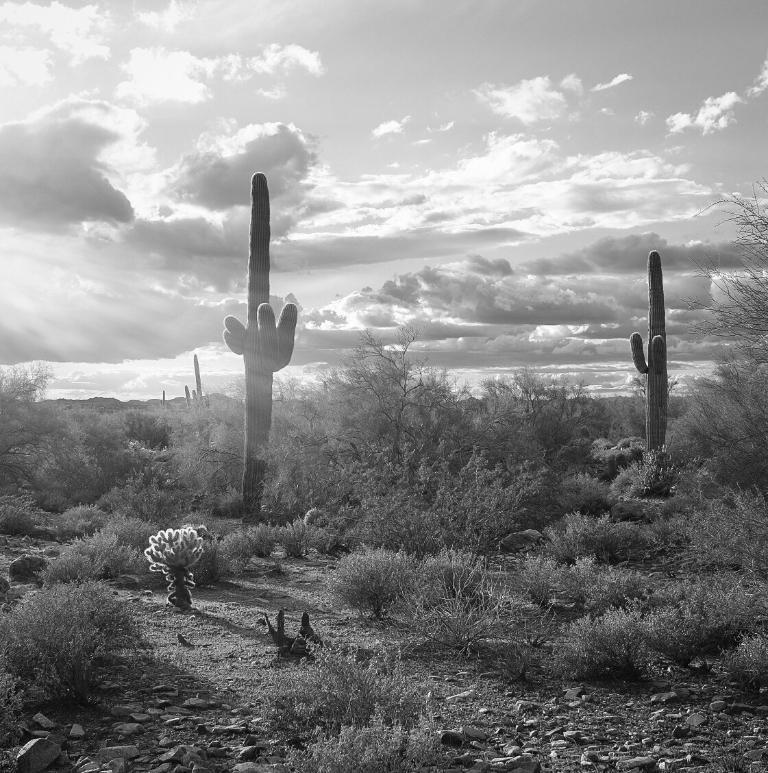What type of vegetation can be seen in the image? There are trees, plants, and grass visible in the image. What is visible at the top of the image? The sky is visible at the top of the image. What can be seen in the sky? Clouds are present in the sky. What type of glove is being used to manipulate the clouds in the image? There is no glove present in the image, and the clouds are not being manipulated. What thought process is being depicted in the image? The image does not depict a thought process; it shows trees, plants, grass, sky, and clouds. 